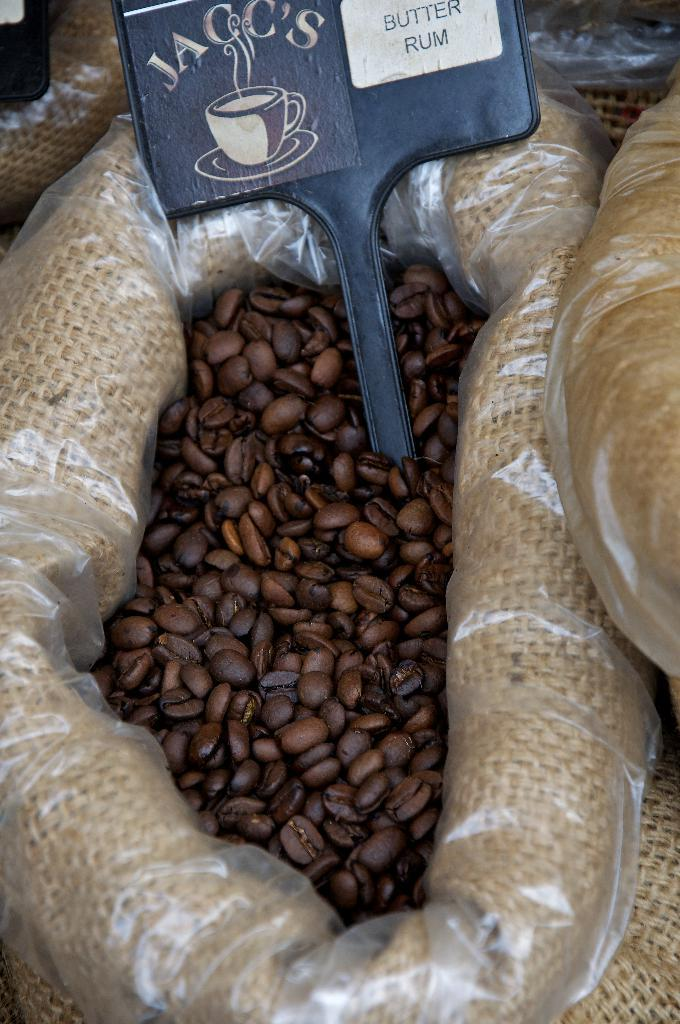What is inside the bag that is visible in the image? There are coffee beans in a bag in the image. What is placed on top of the bag with coffee beans? There is a name board on top of the coffee beans. Are there any other bags in the image? Yes, there are other bags beside the bag with coffee beans. Can you see a shoe on top of the coffee beans in the image? No, there is no shoe present in the image. Is there a monkey sitting on the bags in the image? No, there is no monkey present in the image. 